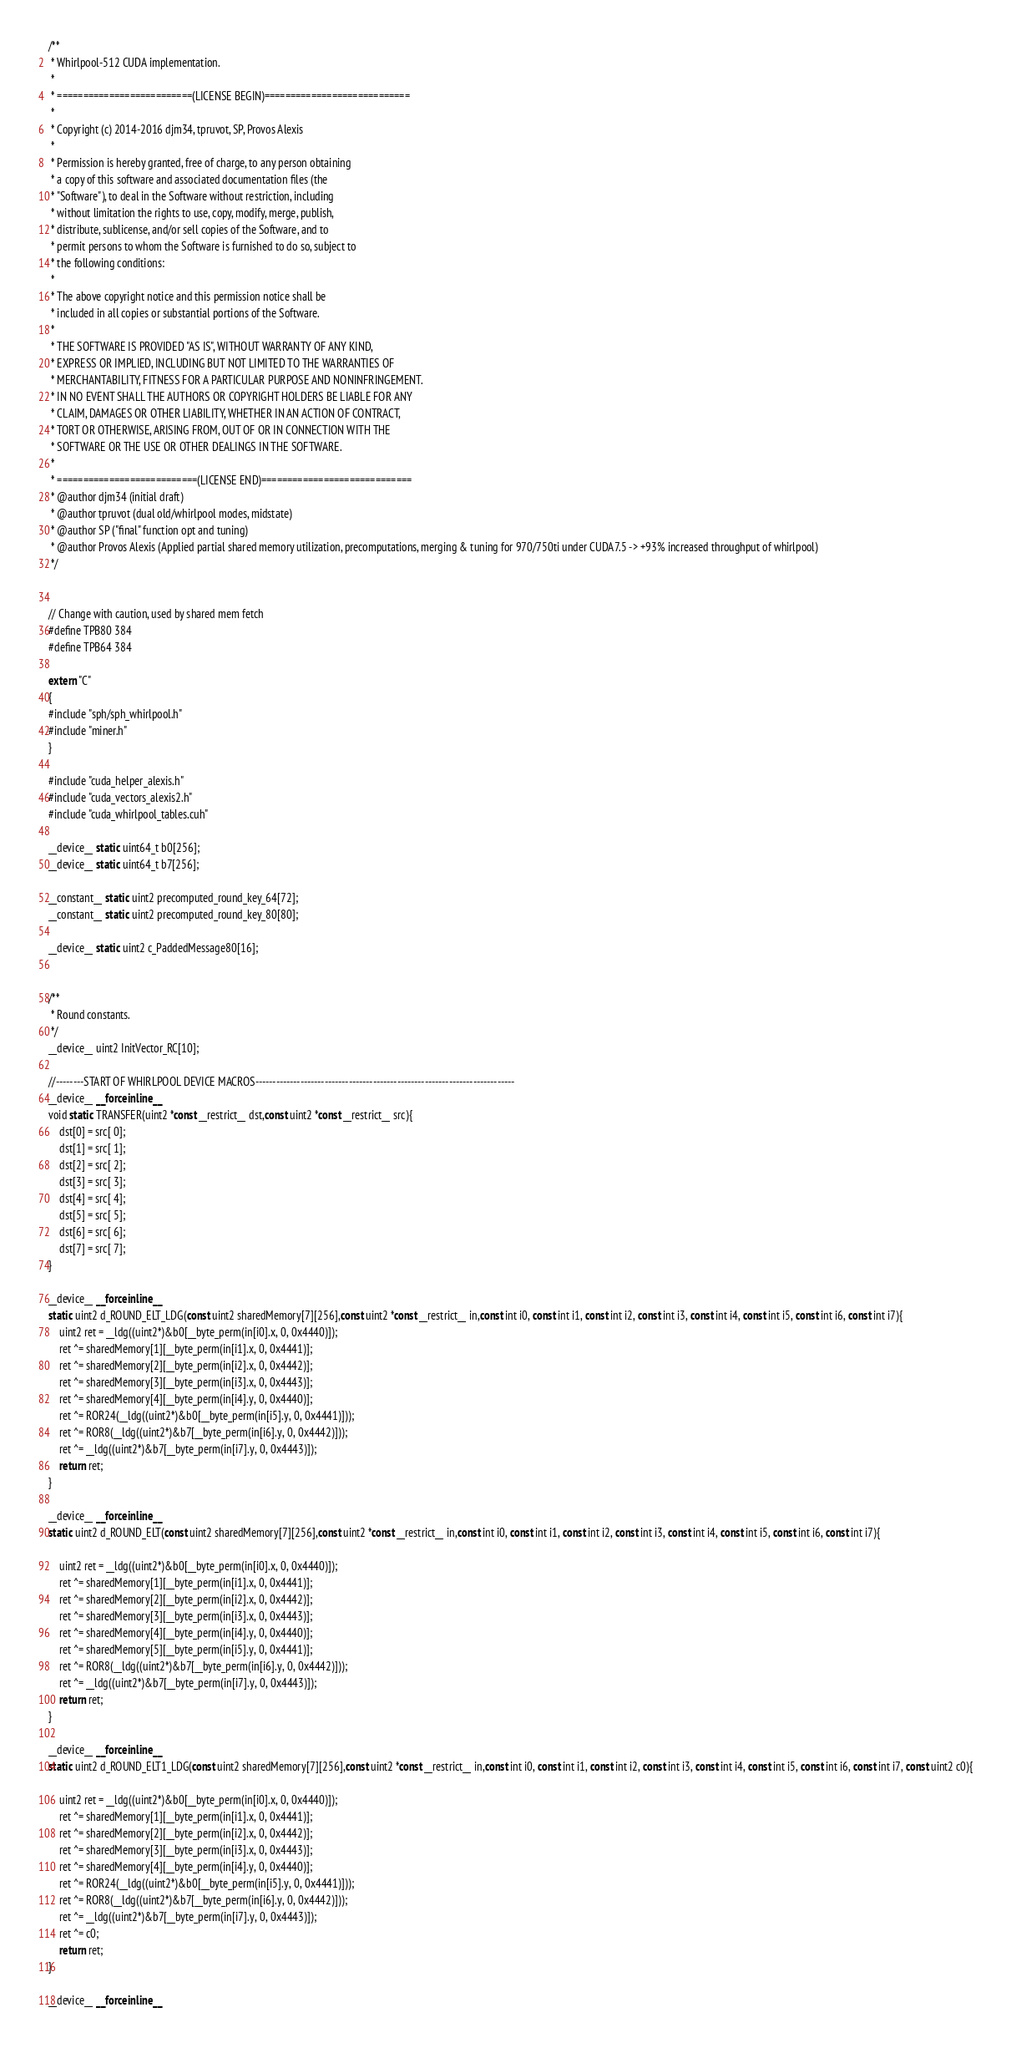Convert code to text. <code><loc_0><loc_0><loc_500><loc_500><_Cuda_>/**
 * Whirlpool-512 CUDA implementation.
 *
 * ==========================(LICENSE BEGIN)============================
 *
 * Copyright (c) 2014-2016 djm34, tpruvot, SP, Provos Alexis
 *
 * Permission is hereby granted, free of charge, to any person obtaining
 * a copy of this software and associated documentation files (the
 * "Software"), to deal in the Software without restriction, including
 * without limitation the rights to use, copy, modify, merge, publish,
 * distribute, sublicense, and/or sell copies of the Software, and to
 * permit persons to whom the Software is furnished to do so, subject to
 * the following conditions:
 *
 * The above copyright notice and this permission notice shall be
 * included in all copies or substantial portions of the Software.
 *
 * THE SOFTWARE IS PROVIDED "AS IS", WITHOUT WARRANTY OF ANY KIND,
 * EXPRESS OR IMPLIED, INCLUDING BUT NOT LIMITED TO THE WARRANTIES OF
 * MERCHANTABILITY, FITNESS FOR A PARTICULAR PURPOSE AND NONINFRINGEMENT.
 * IN NO EVENT SHALL THE AUTHORS OR COPYRIGHT HOLDERS BE LIABLE FOR ANY
 * CLAIM, DAMAGES OR OTHER LIABILITY, WHETHER IN AN ACTION OF CONTRACT,
 * TORT OR OTHERWISE, ARISING FROM, OUT OF OR IN CONNECTION WITH THE
 * SOFTWARE OR THE USE OR OTHER DEALINGS IN THE SOFTWARE.
 *
 * ===========================(LICENSE END)=============================
 * @author djm34 (initial draft)
 * @author tpruvot (dual old/whirlpool modes, midstate)
 * @author SP ("final" function opt and tuning)
 * @author Provos Alexis (Applied partial shared memory utilization, precomputations, merging & tuning for 970/750ti under CUDA7.5 -> +93% increased throughput of whirlpool)
 */


// Change with caution, used by shared mem fetch
#define TPB80 384
#define TPB64 384

extern "C"
{
#include "sph/sph_whirlpool.h"
#include "miner.h"
}

#include "cuda_helper_alexis.h"
#include "cuda_vectors_alexis2.h"
#include "cuda_whirlpool_tables.cuh"

__device__ static uint64_t b0[256];
__device__ static uint64_t b7[256];

__constant__ static uint2 precomputed_round_key_64[72];
__constant__ static uint2 precomputed_round_key_80[80];

__device__ static uint2 c_PaddedMessage80[16];


/**
 * Round constants.
 */
__device__ uint2 InitVector_RC[10];

//--------START OF WHIRLPOOL DEVICE MACROS---------------------------------------------------------------------------
__device__ __forceinline__
void static TRANSFER(uint2 *const __restrict__ dst,const uint2 *const __restrict__ src){
	dst[0] = src[ 0];
	dst[1] = src[ 1];
	dst[2] = src[ 2];
	dst[3] = src[ 3];
	dst[4] = src[ 4];
	dst[5] = src[ 5];
	dst[6] = src[ 6];
	dst[7] = src[ 7];
}

__device__ __forceinline__
static uint2 d_ROUND_ELT_LDG(const uint2 sharedMemory[7][256],const uint2 *const __restrict__ in,const int i0, const int i1, const int i2, const int i3, const int i4, const int i5, const int i6, const int i7){
	uint2 ret = __ldg((uint2*)&b0[__byte_perm(in[i0].x, 0, 0x4440)]);
	ret ^= sharedMemory[1][__byte_perm(in[i1].x, 0, 0x4441)];
	ret ^= sharedMemory[2][__byte_perm(in[i2].x, 0, 0x4442)];
	ret ^= sharedMemory[3][__byte_perm(in[i3].x, 0, 0x4443)];
	ret ^= sharedMemory[4][__byte_perm(in[i4].y, 0, 0x4440)];
	ret ^= ROR24(__ldg((uint2*)&b0[__byte_perm(in[i5].y, 0, 0x4441)]));
	ret ^= ROR8(__ldg((uint2*)&b7[__byte_perm(in[i6].y, 0, 0x4442)]));
	ret ^= __ldg((uint2*)&b7[__byte_perm(in[i7].y, 0, 0x4443)]);
	return ret;
}

__device__ __forceinline__
static uint2 d_ROUND_ELT(const uint2 sharedMemory[7][256],const uint2 *const __restrict__ in,const int i0, const int i1, const int i2, const int i3, const int i4, const int i5, const int i6, const int i7){

	uint2 ret = __ldg((uint2*)&b0[__byte_perm(in[i0].x, 0, 0x4440)]);
	ret ^= sharedMemory[1][__byte_perm(in[i1].x, 0, 0x4441)];
	ret ^= sharedMemory[2][__byte_perm(in[i2].x, 0, 0x4442)];
	ret ^= sharedMemory[3][__byte_perm(in[i3].x, 0, 0x4443)];
	ret ^= sharedMemory[4][__byte_perm(in[i4].y, 0, 0x4440)];
	ret ^= sharedMemory[5][__byte_perm(in[i5].y, 0, 0x4441)];
	ret ^= ROR8(__ldg((uint2*)&b7[__byte_perm(in[i6].y, 0, 0x4442)]));
	ret ^= __ldg((uint2*)&b7[__byte_perm(in[i7].y, 0, 0x4443)]);
	return ret;
}

__device__ __forceinline__
static uint2 d_ROUND_ELT1_LDG(const uint2 sharedMemory[7][256],const uint2 *const __restrict__ in,const int i0, const int i1, const int i2, const int i3, const int i4, const int i5, const int i6, const int i7, const uint2 c0){

	uint2 ret = __ldg((uint2*)&b0[__byte_perm(in[i0].x, 0, 0x4440)]);
	ret ^= sharedMemory[1][__byte_perm(in[i1].x, 0, 0x4441)];
	ret ^= sharedMemory[2][__byte_perm(in[i2].x, 0, 0x4442)];
	ret ^= sharedMemory[3][__byte_perm(in[i3].x, 0, 0x4443)];
	ret ^= sharedMemory[4][__byte_perm(in[i4].y, 0, 0x4440)];
	ret ^= ROR24(__ldg((uint2*)&b0[__byte_perm(in[i5].y, 0, 0x4441)]));
	ret ^= ROR8(__ldg((uint2*)&b7[__byte_perm(in[i6].y, 0, 0x4442)]));
	ret ^= __ldg((uint2*)&b7[__byte_perm(in[i7].y, 0, 0x4443)]);
	ret ^= c0;
	return ret;
}

__device__ __forceinline__</code> 